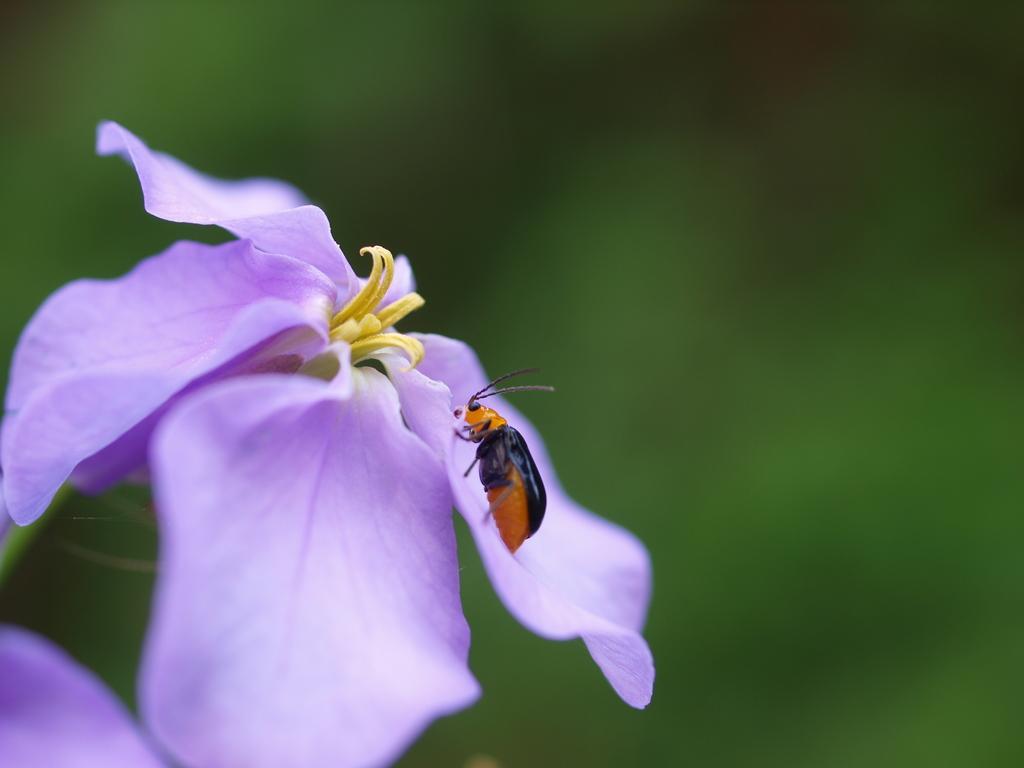How would you summarize this image in a sentence or two? In this image I can see an insect on the flower. An insect is in black and orange color and the flower is in yellow and purple color. 